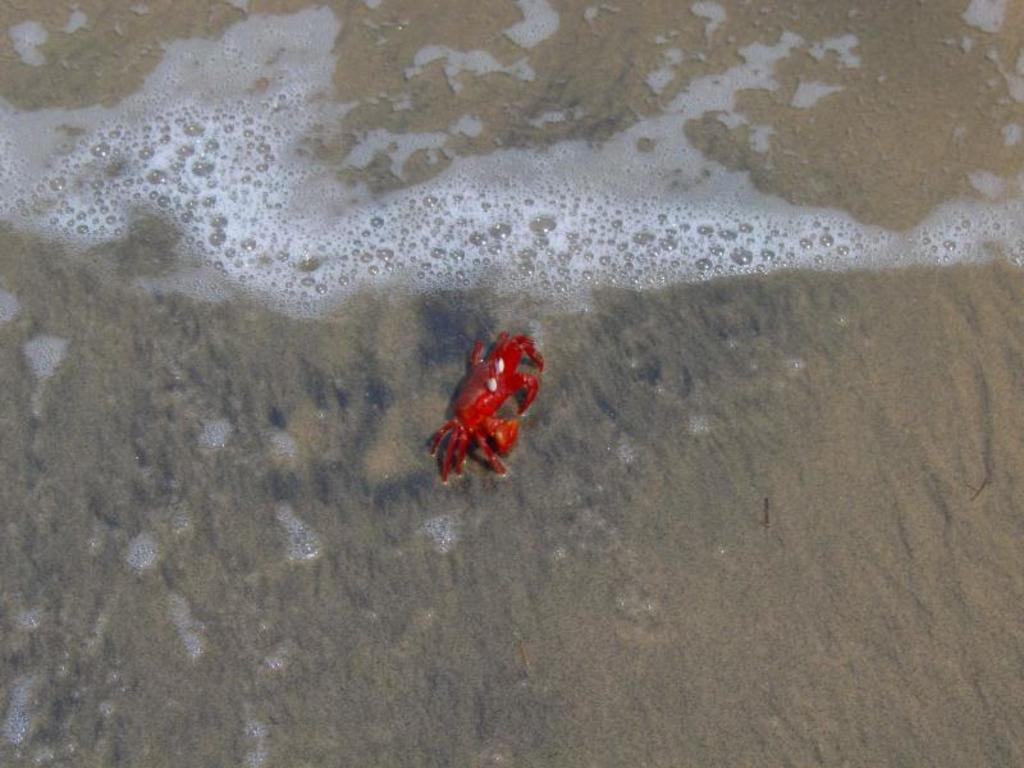What is the main subject in the center of the image? There is a crab in the center of the image. What type of environment is depicted in the image? The image shows a water and sand environment. Can you describe the water in the image? There is water visible in the image. What is at the bottom of the image? There is sand at the bottom of the image. What type of game is being played on the stage in the image? There is no stage or game present in the image; it features a crab in a water and sand environment. Can you describe the ball used in the game in the image? There is no ball or game present in the image. 